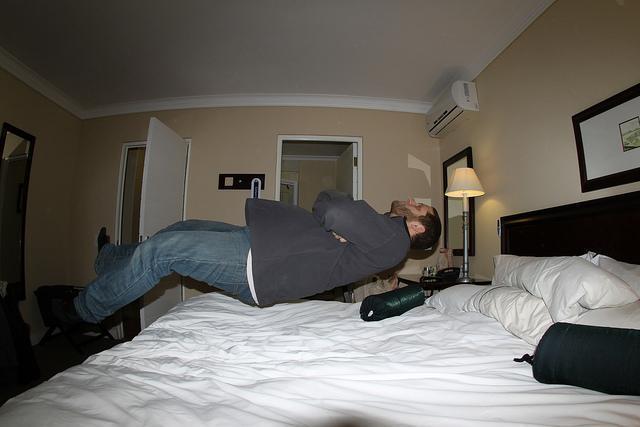The man here is posing to mimic what?
Pick the correct solution from the four options below to address the question.
Options: Drunkenness, levitation, working out, insomnia. Levitation. 